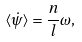<formula> <loc_0><loc_0><loc_500><loc_500>\langle \dot { \psi } \rangle = \frac { n } { l } \omega ,</formula> 